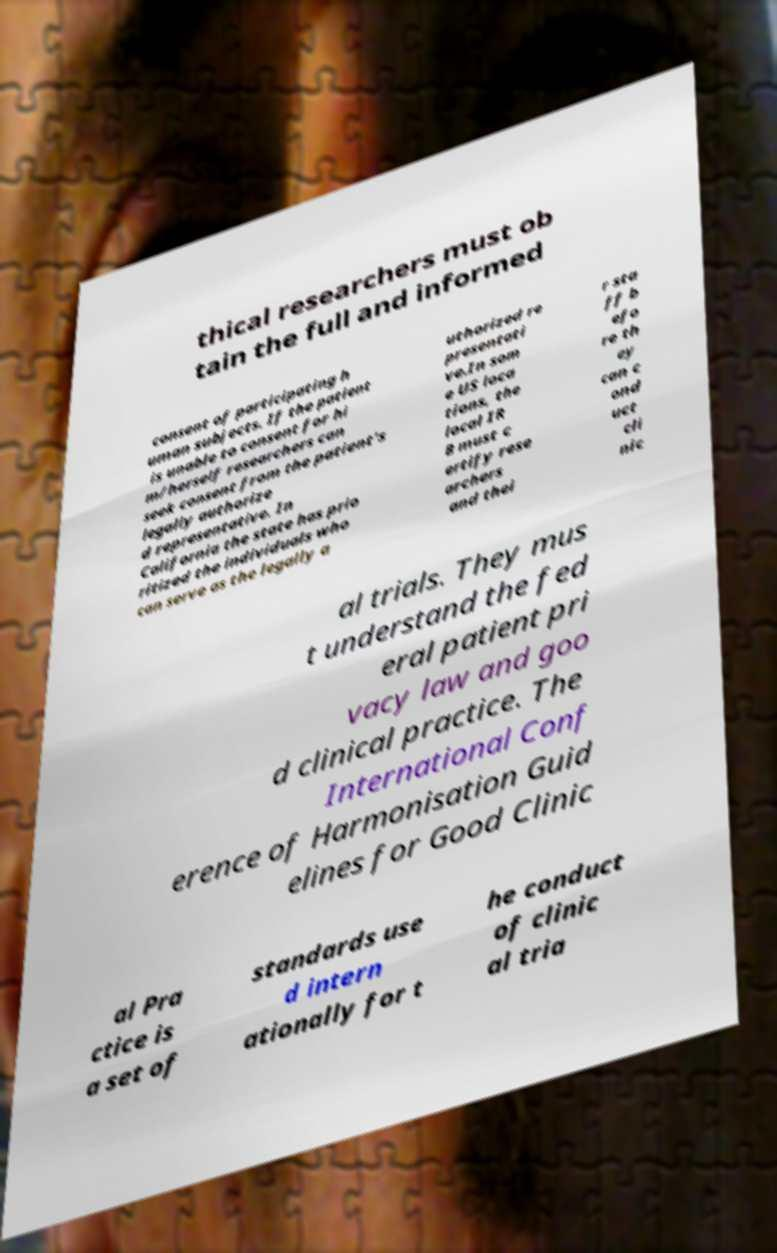Please identify and transcribe the text found in this image. thical researchers must ob tain the full and informed consent of participating h uman subjects. If the patient is unable to consent for hi m/herself researchers can seek consent from the patient's legally authorize d representative. In California the state has prio ritized the individuals who can serve as the legally a uthorized re presentati ve.In som e US loca tions, the local IR B must c ertify rese archers and thei r sta ff b efo re th ey can c ond uct cli nic al trials. They mus t understand the fed eral patient pri vacy law and goo d clinical practice. The International Conf erence of Harmonisation Guid elines for Good Clinic al Pra ctice is a set of standards use d intern ationally for t he conduct of clinic al tria 